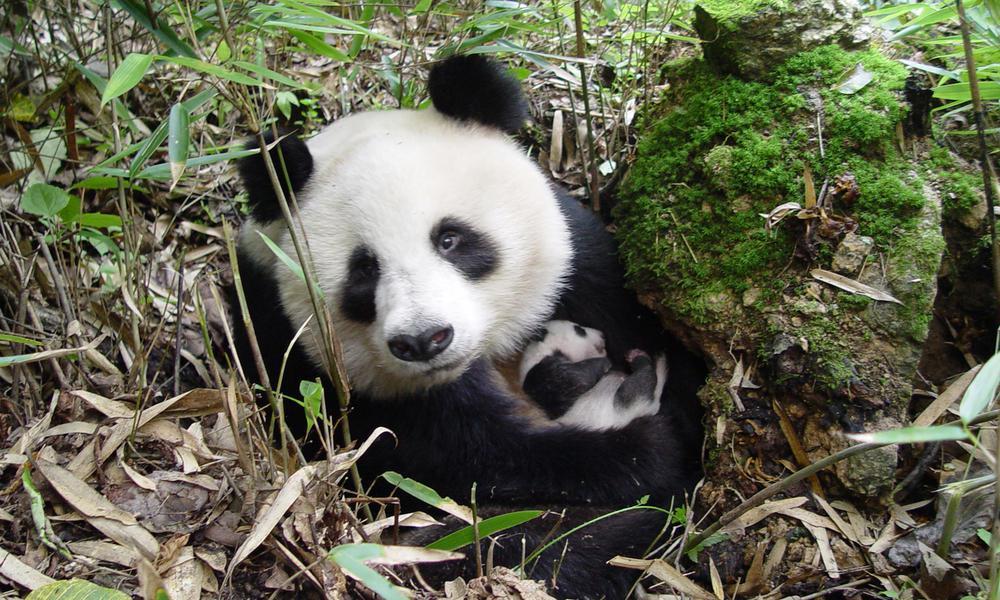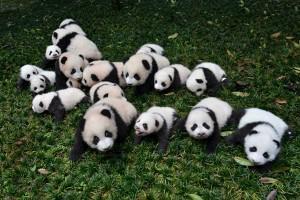The first image is the image on the left, the second image is the image on the right. Analyze the images presented: Is the assertion "A giant panda is frolicking outside." valid? Answer yes or no. Yes. 